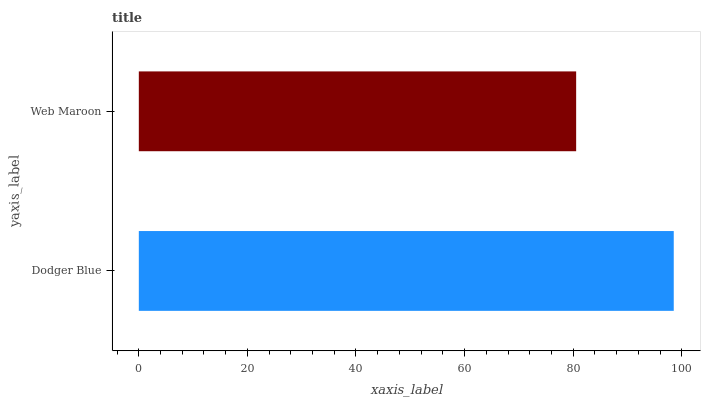Is Web Maroon the minimum?
Answer yes or no. Yes. Is Dodger Blue the maximum?
Answer yes or no. Yes. Is Web Maroon the maximum?
Answer yes or no. No. Is Dodger Blue greater than Web Maroon?
Answer yes or no. Yes. Is Web Maroon less than Dodger Blue?
Answer yes or no. Yes. Is Web Maroon greater than Dodger Blue?
Answer yes or no. No. Is Dodger Blue less than Web Maroon?
Answer yes or no. No. Is Dodger Blue the high median?
Answer yes or no. Yes. Is Web Maroon the low median?
Answer yes or no. Yes. Is Web Maroon the high median?
Answer yes or no. No. Is Dodger Blue the low median?
Answer yes or no. No. 